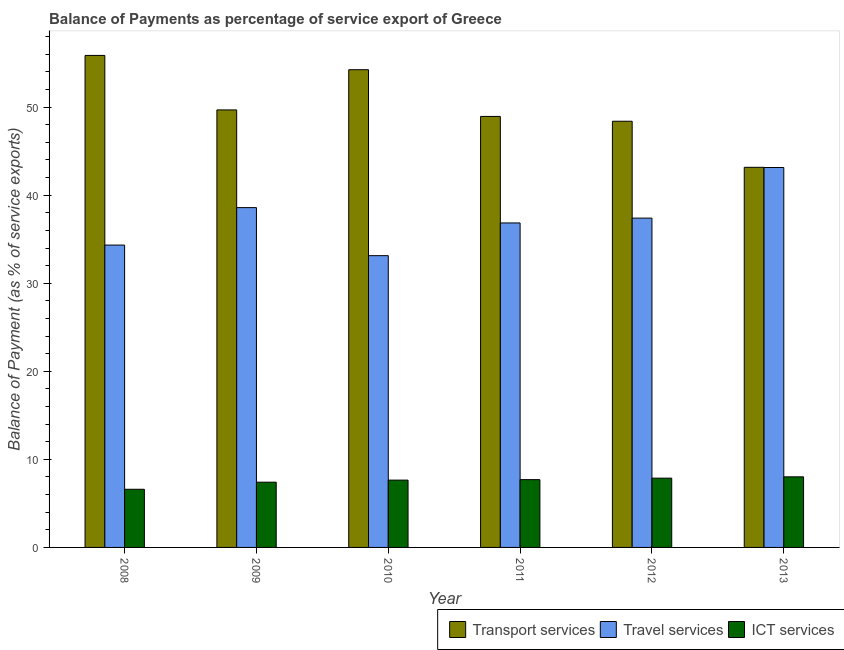Are the number of bars on each tick of the X-axis equal?
Give a very brief answer. Yes. How many bars are there on the 5th tick from the left?
Offer a terse response. 3. How many bars are there on the 6th tick from the right?
Keep it short and to the point. 3. What is the label of the 3rd group of bars from the left?
Give a very brief answer. 2010. What is the balance of payment of ict services in 2008?
Keep it short and to the point. 6.6. Across all years, what is the maximum balance of payment of ict services?
Your answer should be very brief. 8.02. Across all years, what is the minimum balance of payment of travel services?
Provide a succinct answer. 33.13. In which year was the balance of payment of transport services maximum?
Offer a terse response. 2008. In which year was the balance of payment of transport services minimum?
Your answer should be compact. 2013. What is the total balance of payment of ict services in the graph?
Offer a terse response. 45.24. What is the difference between the balance of payment of transport services in 2008 and that in 2011?
Provide a short and direct response. 6.93. What is the difference between the balance of payment of ict services in 2010 and the balance of payment of transport services in 2008?
Give a very brief answer. 1.04. What is the average balance of payment of ict services per year?
Give a very brief answer. 7.54. In the year 2010, what is the difference between the balance of payment of transport services and balance of payment of ict services?
Your answer should be compact. 0. In how many years, is the balance of payment of transport services greater than 40 %?
Ensure brevity in your answer.  6. What is the ratio of the balance of payment of ict services in 2008 to that in 2013?
Offer a terse response. 0.82. Is the difference between the balance of payment of travel services in 2009 and 2011 greater than the difference between the balance of payment of ict services in 2009 and 2011?
Your response must be concise. No. What is the difference between the highest and the second highest balance of payment of ict services?
Provide a short and direct response. 0.15. What is the difference between the highest and the lowest balance of payment of transport services?
Give a very brief answer. 12.71. What does the 1st bar from the left in 2009 represents?
Your response must be concise. Transport services. What does the 3rd bar from the right in 2008 represents?
Offer a very short reply. Transport services. Is it the case that in every year, the sum of the balance of payment of transport services and balance of payment of travel services is greater than the balance of payment of ict services?
Keep it short and to the point. Yes. What is the difference between two consecutive major ticks on the Y-axis?
Your response must be concise. 10. Are the values on the major ticks of Y-axis written in scientific E-notation?
Your response must be concise. No. Where does the legend appear in the graph?
Ensure brevity in your answer.  Bottom right. How are the legend labels stacked?
Give a very brief answer. Horizontal. What is the title of the graph?
Your answer should be very brief. Balance of Payments as percentage of service export of Greece. Does "Secondary education" appear as one of the legend labels in the graph?
Your response must be concise. No. What is the label or title of the X-axis?
Give a very brief answer. Year. What is the label or title of the Y-axis?
Provide a short and direct response. Balance of Payment (as % of service exports). What is the Balance of Payment (as % of service exports) in Transport services in 2008?
Your response must be concise. 55.87. What is the Balance of Payment (as % of service exports) of Travel services in 2008?
Provide a succinct answer. 34.33. What is the Balance of Payment (as % of service exports) in ICT services in 2008?
Offer a terse response. 6.6. What is the Balance of Payment (as % of service exports) in Transport services in 2009?
Your response must be concise. 49.68. What is the Balance of Payment (as % of service exports) in Travel services in 2009?
Offer a terse response. 38.59. What is the Balance of Payment (as % of service exports) of ICT services in 2009?
Ensure brevity in your answer.  7.41. What is the Balance of Payment (as % of service exports) in Transport services in 2010?
Your answer should be very brief. 54.25. What is the Balance of Payment (as % of service exports) of Travel services in 2010?
Give a very brief answer. 33.13. What is the Balance of Payment (as % of service exports) of ICT services in 2010?
Keep it short and to the point. 7.64. What is the Balance of Payment (as % of service exports) of Transport services in 2011?
Make the answer very short. 48.94. What is the Balance of Payment (as % of service exports) in Travel services in 2011?
Provide a succinct answer. 36.85. What is the Balance of Payment (as % of service exports) of ICT services in 2011?
Give a very brief answer. 7.7. What is the Balance of Payment (as % of service exports) in Transport services in 2012?
Offer a very short reply. 48.39. What is the Balance of Payment (as % of service exports) of Travel services in 2012?
Offer a very short reply. 37.39. What is the Balance of Payment (as % of service exports) of ICT services in 2012?
Your response must be concise. 7.87. What is the Balance of Payment (as % of service exports) in Transport services in 2013?
Provide a succinct answer. 43.16. What is the Balance of Payment (as % of service exports) in Travel services in 2013?
Give a very brief answer. 43.14. What is the Balance of Payment (as % of service exports) of ICT services in 2013?
Keep it short and to the point. 8.02. Across all years, what is the maximum Balance of Payment (as % of service exports) in Transport services?
Your answer should be very brief. 55.87. Across all years, what is the maximum Balance of Payment (as % of service exports) of Travel services?
Your response must be concise. 43.14. Across all years, what is the maximum Balance of Payment (as % of service exports) in ICT services?
Keep it short and to the point. 8.02. Across all years, what is the minimum Balance of Payment (as % of service exports) in Transport services?
Give a very brief answer. 43.16. Across all years, what is the minimum Balance of Payment (as % of service exports) of Travel services?
Your response must be concise. 33.13. Across all years, what is the minimum Balance of Payment (as % of service exports) in ICT services?
Make the answer very short. 6.6. What is the total Balance of Payment (as % of service exports) of Transport services in the graph?
Provide a short and direct response. 300.29. What is the total Balance of Payment (as % of service exports) in Travel services in the graph?
Your answer should be very brief. 223.43. What is the total Balance of Payment (as % of service exports) of ICT services in the graph?
Your response must be concise. 45.24. What is the difference between the Balance of Payment (as % of service exports) of Transport services in 2008 and that in 2009?
Ensure brevity in your answer.  6.19. What is the difference between the Balance of Payment (as % of service exports) of Travel services in 2008 and that in 2009?
Give a very brief answer. -4.25. What is the difference between the Balance of Payment (as % of service exports) of ICT services in 2008 and that in 2009?
Your answer should be very brief. -0.8. What is the difference between the Balance of Payment (as % of service exports) in Transport services in 2008 and that in 2010?
Your answer should be compact. 1.62. What is the difference between the Balance of Payment (as % of service exports) in Travel services in 2008 and that in 2010?
Provide a short and direct response. 1.2. What is the difference between the Balance of Payment (as % of service exports) in ICT services in 2008 and that in 2010?
Provide a succinct answer. -1.04. What is the difference between the Balance of Payment (as % of service exports) of Transport services in 2008 and that in 2011?
Offer a very short reply. 6.93. What is the difference between the Balance of Payment (as % of service exports) of Travel services in 2008 and that in 2011?
Offer a very short reply. -2.51. What is the difference between the Balance of Payment (as % of service exports) of ICT services in 2008 and that in 2011?
Make the answer very short. -1.09. What is the difference between the Balance of Payment (as % of service exports) in Transport services in 2008 and that in 2012?
Offer a terse response. 7.47. What is the difference between the Balance of Payment (as % of service exports) in Travel services in 2008 and that in 2012?
Keep it short and to the point. -3.06. What is the difference between the Balance of Payment (as % of service exports) of ICT services in 2008 and that in 2012?
Your answer should be very brief. -1.26. What is the difference between the Balance of Payment (as % of service exports) in Transport services in 2008 and that in 2013?
Your response must be concise. 12.71. What is the difference between the Balance of Payment (as % of service exports) of Travel services in 2008 and that in 2013?
Your response must be concise. -8.81. What is the difference between the Balance of Payment (as % of service exports) of ICT services in 2008 and that in 2013?
Give a very brief answer. -1.41. What is the difference between the Balance of Payment (as % of service exports) in Transport services in 2009 and that in 2010?
Make the answer very short. -4.57. What is the difference between the Balance of Payment (as % of service exports) of Travel services in 2009 and that in 2010?
Provide a short and direct response. 5.46. What is the difference between the Balance of Payment (as % of service exports) in ICT services in 2009 and that in 2010?
Make the answer very short. -0.24. What is the difference between the Balance of Payment (as % of service exports) in Transport services in 2009 and that in 2011?
Keep it short and to the point. 0.74. What is the difference between the Balance of Payment (as % of service exports) in Travel services in 2009 and that in 2011?
Ensure brevity in your answer.  1.74. What is the difference between the Balance of Payment (as % of service exports) of ICT services in 2009 and that in 2011?
Provide a short and direct response. -0.29. What is the difference between the Balance of Payment (as % of service exports) in Transport services in 2009 and that in 2012?
Ensure brevity in your answer.  1.29. What is the difference between the Balance of Payment (as % of service exports) in Travel services in 2009 and that in 2012?
Ensure brevity in your answer.  1.19. What is the difference between the Balance of Payment (as % of service exports) in ICT services in 2009 and that in 2012?
Keep it short and to the point. -0.46. What is the difference between the Balance of Payment (as % of service exports) in Transport services in 2009 and that in 2013?
Your answer should be compact. 6.52. What is the difference between the Balance of Payment (as % of service exports) in Travel services in 2009 and that in 2013?
Ensure brevity in your answer.  -4.55. What is the difference between the Balance of Payment (as % of service exports) of ICT services in 2009 and that in 2013?
Your response must be concise. -0.61. What is the difference between the Balance of Payment (as % of service exports) of Transport services in 2010 and that in 2011?
Your answer should be very brief. 5.31. What is the difference between the Balance of Payment (as % of service exports) of Travel services in 2010 and that in 2011?
Your response must be concise. -3.72. What is the difference between the Balance of Payment (as % of service exports) of ICT services in 2010 and that in 2011?
Give a very brief answer. -0.05. What is the difference between the Balance of Payment (as % of service exports) in Transport services in 2010 and that in 2012?
Your answer should be compact. 5.85. What is the difference between the Balance of Payment (as % of service exports) of Travel services in 2010 and that in 2012?
Offer a very short reply. -4.26. What is the difference between the Balance of Payment (as % of service exports) in ICT services in 2010 and that in 2012?
Ensure brevity in your answer.  -0.22. What is the difference between the Balance of Payment (as % of service exports) in Transport services in 2010 and that in 2013?
Your answer should be very brief. 11.08. What is the difference between the Balance of Payment (as % of service exports) in Travel services in 2010 and that in 2013?
Offer a terse response. -10.01. What is the difference between the Balance of Payment (as % of service exports) of ICT services in 2010 and that in 2013?
Your response must be concise. -0.37. What is the difference between the Balance of Payment (as % of service exports) in Transport services in 2011 and that in 2012?
Provide a succinct answer. 0.55. What is the difference between the Balance of Payment (as % of service exports) in Travel services in 2011 and that in 2012?
Your answer should be compact. -0.55. What is the difference between the Balance of Payment (as % of service exports) of ICT services in 2011 and that in 2012?
Your answer should be very brief. -0.17. What is the difference between the Balance of Payment (as % of service exports) of Transport services in 2011 and that in 2013?
Keep it short and to the point. 5.78. What is the difference between the Balance of Payment (as % of service exports) of Travel services in 2011 and that in 2013?
Offer a very short reply. -6.3. What is the difference between the Balance of Payment (as % of service exports) in ICT services in 2011 and that in 2013?
Ensure brevity in your answer.  -0.32. What is the difference between the Balance of Payment (as % of service exports) in Transport services in 2012 and that in 2013?
Your answer should be very brief. 5.23. What is the difference between the Balance of Payment (as % of service exports) in Travel services in 2012 and that in 2013?
Keep it short and to the point. -5.75. What is the difference between the Balance of Payment (as % of service exports) in ICT services in 2012 and that in 2013?
Your answer should be very brief. -0.15. What is the difference between the Balance of Payment (as % of service exports) of Transport services in 2008 and the Balance of Payment (as % of service exports) of Travel services in 2009?
Provide a succinct answer. 17.28. What is the difference between the Balance of Payment (as % of service exports) in Transport services in 2008 and the Balance of Payment (as % of service exports) in ICT services in 2009?
Offer a terse response. 48.46. What is the difference between the Balance of Payment (as % of service exports) of Travel services in 2008 and the Balance of Payment (as % of service exports) of ICT services in 2009?
Your answer should be very brief. 26.93. What is the difference between the Balance of Payment (as % of service exports) of Transport services in 2008 and the Balance of Payment (as % of service exports) of Travel services in 2010?
Make the answer very short. 22.74. What is the difference between the Balance of Payment (as % of service exports) of Transport services in 2008 and the Balance of Payment (as % of service exports) of ICT services in 2010?
Ensure brevity in your answer.  48.22. What is the difference between the Balance of Payment (as % of service exports) in Travel services in 2008 and the Balance of Payment (as % of service exports) in ICT services in 2010?
Give a very brief answer. 26.69. What is the difference between the Balance of Payment (as % of service exports) of Transport services in 2008 and the Balance of Payment (as % of service exports) of Travel services in 2011?
Offer a very short reply. 19.02. What is the difference between the Balance of Payment (as % of service exports) of Transport services in 2008 and the Balance of Payment (as % of service exports) of ICT services in 2011?
Keep it short and to the point. 48.17. What is the difference between the Balance of Payment (as % of service exports) of Travel services in 2008 and the Balance of Payment (as % of service exports) of ICT services in 2011?
Give a very brief answer. 26.64. What is the difference between the Balance of Payment (as % of service exports) in Transport services in 2008 and the Balance of Payment (as % of service exports) in Travel services in 2012?
Ensure brevity in your answer.  18.47. What is the difference between the Balance of Payment (as % of service exports) of Transport services in 2008 and the Balance of Payment (as % of service exports) of ICT services in 2012?
Offer a very short reply. 48. What is the difference between the Balance of Payment (as % of service exports) in Travel services in 2008 and the Balance of Payment (as % of service exports) in ICT services in 2012?
Keep it short and to the point. 26.47. What is the difference between the Balance of Payment (as % of service exports) of Transport services in 2008 and the Balance of Payment (as % of service exports) of Travel services in 2013?
Keep it short and to the point. 12.73. What is the difference between the Balance of Payment (as % of service exports) in Transport services in 2008 and the Balance of Payment (as % of service exports) in ICT services in 2013?
Your answer should be very brief. 47.85. What is the difference between the Balance of Payment (as % of service exports) in Travel services in 2008 and the Balance of Payment (as % of service exports) in ICT services in 2013?
Keep it short and to the point. 26.32. What is the difference between the Balance of Payment (as % of service exports) of Transport services in 2009 and the Balance of Payment (as % of service exports) of Travel services in 2010?
Your response must be concise. 16.55. What is the difference between the Balance of Payment (as % of service exports) of Transport services in 2009 and the Balance of Payment (as % of service exports) of ICT services in 2010?
Keep it short and to the point. 42.04. What is the difference between the Balance of Payment (as % of service exports) of Travel services in 2009 and the Balance of Payment (as % of service exports) of ICT services in 2010?
Provide a succinct answer. 30.94. What is the difference between the Balance of Payment (as % of service exports) of Transport services in 2009 and the Balance of Payment (as % of service exports) of Travel services in 2011?
Give a very brief answer. 12.83. What is the difference between the Balance of Payment (as % of service exports) in Transport services in 2009 and the Balance of Payment (as % of service exports) in ICT services in 2011?
Offer a terse response. 41.98. What is the difference between the Balance of Payment (as % of service exports) in Travel services in 2009 and the Balance of Payment (as % of service exports) in ICT services in 2011?
Provide a short and direct response. 30.89. What is the difference between the Balance of Payment (as % of service exports) of Transport services in 2009 and the Balance of Payment (as % of service exports) of Travel services in 2012?
Your answer should be compact. 12.29. What is the difference between the Balance of Payment (as % of service exports) of Transport services in 2009 and the Balance of Payment (as % of service exports) of ICT services in 2012?
Provide a short and direct response. 41.81. What is the difference between the Balance of Payment (as % of service exports) of Travel services in 2009 and the Balance of Payment (as % of service exports) of ICT services in 2012?
Keep it short and to the point. 30.72. What is the difference between the Balance of Payment (as % of service exports) of Transport services in 2009 and the Balance of Payment (as % of service exports) of Travel services in 2013?
Provide a short and direct response. 6.54. What is the difference between the Balance of Payment (as % of service exports) in Transport services in 2009 and the Balance of Payment (as % of service exports) in ICT services in 2013?
Your answer should be compact. 41.66. What is the difference between the Balance of Payment (as % of service exports) in Travel services in 2009 and the Balance of Payment (as % of service exports) in ICT services in 2013?
Provide a succinct answer. 30.57. What is the difference between the Balance of Payment (as % of service exports) of Transport services in 2010 and the Balance of Payment (as % of service exports) of Travel services in 2011?
Provide a short and direct response. 17.4. What is the difference between the Balance of Payment (as % of service exports) in Transport services in 2010 and the Balance of Payment (as % of service exports) in ICT services in 2011?
Give a very brief answer. 46.55. What is the difference between the Balance of Payment (as % of service exports) of Travel services in 2010 and the Balance of Payment (as % of service exports) of ICT services in 2011?
Your answer should be compact. 25.43. What is the difference between the Balance of Payment (as % of service exports) of Transport services in 2010 and the Balance of Payment (as % of service exports) of Travel services in 2012?
Provide a succinct answer. 16.85. What is the difference between the Balance of Payment (as % of service exports) in Transport services in 2010 and the Balance of Payment (as % of service exports) in ICT services in 2012?
Provide a succinct answer. 46.38. What is the difference between the Balance of Payment (as % of service exports) in Travel services in 2010 and the Balance of Payment (as % of service exports) in ICT services in 2012?
Give a very brief answer. 25.26. What is the difference between the Balance of Payment (as % of service exports) of Transport services in 2010 and the Balance of Payment (as % of service exports) of Travel services in 2013?
Your answer should be very brief. 11.1. What is the difference between the Balance of Payment (as % of service exports) in Transport services in 2010 and the Balance of Payment (as % of service exports) in ICT services in 2013?
Your response must be concise. 46.23. What is the difference between the Balance of Payment (as % of service exports) in Travel services in 2010 and the Balance of Payment (as % of service exports) in ICT services in 2013?
Offer a very short reply. 25.11. What is the difference between the Balance of Payment (as % of service exports) of Transport services in 2011 and the Balance of Payment (as % of service exports) of Travel services in 2012?
Make the answer very short. 11.55. What is the difference between the Balance of Payment (as % of service exports) of Transport services in 2011 and the Balance of Payment (as % of service exports) of ICT services in 2012?
Your answer should be compact. 41.07. What is the difference between the Balance of Payment (as % of service exports) in Travel services in 2011 and the Balance of Payment (as % of service exports) in ICT services in 2012?
Give a very brief answer. 28.98. What is the difference between the Balance of Payment (as % of service exports) in Transport services in 2011 and the Balance of Payment (as % of service exports) in Travel services in 2013?
Offer a very short reply. 5.8. What is the difference between the Balance of Payment (as % of service exports) in Transport services in 2011 and the Balance of Payment (as % of service exports) in ICT services in 2013?
Your response must be concise. 40.92. What is the difference between the Balance of Payment (as % of service exports) of Travel services in 2011 and the Balance of Payment (as % of service exports) of ICT services in 2013?
Your answer should be very brief. 28.83. What is the difference between the Balance of Payment (as % of service exports) in Transport services in 2012 and the Balance of Payment (as % of service exports) in Travel services in 2013?
Ensure brevity in your answer.  5.25. What is the difference between the Balance of Payment (as % of service exports) of Transport services in 2012 and the Balance of Payment (as % of service exports) of ICT services in 2013?
Ensure brevity in your answer.  40.38. What is the difference between the Balance of Payment (as % of service exports) of Travel services in 2012 and the Balance of Payment (as % of service exports) of ICT services in 2013?
Your answer should be compact. 29.38. What is the average Balance of Payment (as % of service exports) in Transport services per year?
Give a very brief answer. 50.05. What is the average Balance of Payment (as % of service exports) in Travel services per year?
Offer a terse response. 37.24. What is the average Balance of Payment (as % of service exports) in ICT services per year?
Provide a succinct answer. 7.54. In the year 2008, what is the difference between the Balance of Payment (as % of service exports) in Transport services and Balance of Payment (as % of service exports) in Travel services?
Provide a succinct answer. 21.53. In the year 2008, what is the difference between the Balance of Payment (as % of service exports) in Transport services and Balance of Payment (as % of service exports) in ICT services?
Offer a terse response. 49.26. In the year 2008, what is the difference between the Balance of Payment (as % of service exports) of Travel services and Balance of Payment (as % of service exports) of ICT services?
Make the answer very short. 27.73. In the year 2009, what is the difference between the Balance of Payment (as % of service exports) of Transport services and Balance of Payment (as % of service exports) of Travel services?
Your response must be concise. 11.09. In the year 2009, what is the difference between the Balance of Payment (as % of service exports) of Transport services and Balance of Payment (as % of service exports) of ICT services?
Give a very brief answer. 42.27. In the year 2009, what is the difference between the Balance of Payment (as % of service exports) in Travel services and Balance of Payment (as % of service exports) in ICT services?
Your answer should be compact. 31.18. In the year 2010, what is the difference between the Balance of Payment (as % of service exports) in Transport services and Balance of Payment (as % of service exports) in Travel services?
Your answer should be compact. 21.12. In the year 2010, what is the difference between the Balance of Payment (as % of service exports) of Transport services and Balance of Payment (as % of service exports) of ICT services?
Provide a succinct answer. 46.6. In the year 2010, what is the difference between the Balance of Payment (as % of service exports) of Travel services and Balance of Payment (as % of service exports) of ICT services?
Your answer should be very brief. 25.49. In the year 2011, what is the difference between the Balance of Payment (as % of service exports) of Transport services and Balance of Payment (as % of service exports) of Travel services?
Offer a terse response. 12.09. In the year 2011, what is the difference between the Balance of Payment (as % of service exports) of Transport services and Balance of Payment (as % of service exports) of ICT services?
Make the answer very short. 41.24. In the year 2011, what is the difference between the Balance of Payment (as % of service exports) of Travel services and Balance of Payment (as % of service exports) of ICT services?
Keep it short and to the point. 29.15. In the year 2012, what is the difference between the Balance of Payment (as % of service exports) in Transport services and Balance of Payment (as % of service exports) in Travel services?
Ensure brevity in your answer.  11. In the year 2012, what is the difference between the Balance of Payment (as % of service exports) in Transport services and Balance of Payment (as % of service exports) in ICT services?
Provide a short and direct response. 40.53. In the year 2012, what is the difference between the Balance of Payment (as % of service exports) of Travel services and Balance of Payment (as % of service exports) of ICT services?
Your answer should be compact. 29.53. In the year 2013, what is the difference between the Balance of Payment (as % of service exports) in Transport services and Balance of Payment (as % of service exports) in Travel services?
Give a very brief answer. 0.02. In the year 2013, what is the difference between the Balance of Payment (as % of service exports) of Transport services and Balance of Payment (as % of service exports) of ICT services?
Provide a short and direct response. 35.15. In the year 2013, what is the difference between the Balance of Payment (as % of service exports) of Travel services and Balance of Payment (as % of service exports) of ICT services?
Your answer should be very brief. 35.13. What is the ratio of the Balance of Payment (as % of service exports) in Transport services in 2008 to that in 2009?
Keep it short and to the point. 1.12. What is the ratio of the Balance of Payment (as % of service exports) in Travel services in 2008 to that in 2009?
Offer a very short reply. 0.89. What is the ratio of the Balance of Payment (as % of service exports) of ICT services in 2008 to that in 2009?
Provide a succinct answer. 0.89. What is the ratio of the Balance of Payment (as % of service exports) in Transport services in 2008 to that in 2010?
Your answer should be very brief. 1.03. What is the ratio of the Balance of Payment (as % of service exports) of Travel services in 2008 to that in 2010?
Provide a succinct answer. 1.04. What is the ratio of the Balance of Payment (as % of service exports) in ICT services in 2008 to that in 2010?
Provide a succinct answer. 0.86. What is the ratio of the Balance of Payment (as % of service exports) of Transport services in 2008 to that in 2011?
Make the answer very short. 1.14. What is the ratio of the Balance of Payment (as % of service exports) of Travel services in 2008 to that in 2011?
Your answer should be compact. 0.93. What is the ratio of the Balance of Payment (as % of service exports) of ICT services in 2008 to that in 2011?
Your answer should be compact. 0.86. What is the ratio of the Balance of Payment (as % of service exports) of Transport services in 2008 to that in 2012?
Your answer should be very brief. 1.15. What is the ratio of the Balance of Payment (as % of service exports) of Travel services in 2008 to that in 2012?
Provide a short and direct response. 0.92. What is the ratio of the Balance of Payment (as % of service exports) of ICT services in 2008 to that in 2012?
Give a very brief answer. 0.84. What is the ratio of the Balance of Payment (as % of service exports) in Transport services in 2008 to that in 2013?
Provide a succinct answer. 1.29. What is the ratio of the Balance of Payment (as % of service exports) of Travel services in 2008 to that in 2013?
Your answer should be very brief. 0.8. What is the ratio of the Balance of Payment (as % of service exports) in ICT services in 2008 to that in 2013?
Offer a terse response. 0.82. What is the ratio of the Balance of Payment (as % of service exports) of Transport services in 2009 to that in 2010?
Offer a very short reply. 0.92. What is the ratio of the Balance of Payment (as % of service exports) in Travel services in 2009 to that in 2010?
Offer a very short reply. 1.16. What is the ratio of the Balance of Payment (as % of service exports) in ICT services in 2009 to that in 2010?
Your answer should be compact. 0.97. What is the ratio of the Balance of Payment (as % of service exports) of Transport services in 2009 to that in 2011?
Offer a very short reply. 1.02. What is the ratio of the Balance of Payment (as % of service exports) in Travel services in 2009 to that in 2011?
Offer a very short reply. 1.05. What is the ratio of the Balance of Payment (as % of service exports) in ICT services in 2009 to that in 2011?
Make the answer very short. 0.96. What is the ratio of the Balance of Payment (as % of service exports) in Transport services in 2009 to that in 2012?
Your response must be concise. 1.03. What is the ratio of the Balance of Payment (as % of service exports) in Travel services in 2009 to that in 2012?
Ensure brevity in your answer.  1.03. What is the ratio of the Balance of Payment (as % of service exports) in ICT services in 2009 to that in 2012?
Your answer should be compact. 0.94. What is the ratio of the Balance of Payment (as % of service exports) of Transport services in 2009 to that in 2013?
Your answer should be very brief. 1.15. What is the ratio of the Balance of Payment (as % of service exports) of Travel services in 2009 to that in 2013?
Offer a terse response. 0.89. What is the ratio of the Balance of Payment (as % of service exports) of ICT services in 2009 to that in 2013?
Provide a succinct answer. 0.92. What is the ratio of the Balance of Payment (as % of service exports) of Transport services in 2010 to that in 2011?
Ensure brevity in your answer.  1.11. What is the ratio of the Balance of Payment (as % of service exports) in Travel services in 2010 to that in 2011?
Provide a succinct answer. 0.9. What is the ratio of the Balance of Payment (as % of service exports) in ICT services in 2010 to that in 2011?
Your answer should be very brief. 0.99. What is the ratio of the Balance of Payment (as % of service exports) in Transport services in 2010 to that in 2012?
Provide a succinct answer. 1.12. What is the ratio of the Balance of Payment (as % of service exports) of Travel services in 2010 to that in 2012?
Give a very brief answer. 0.89. What is the ratio of the Balance of Payment (as % of service exports) in ICT services in 2010 to that in 2012?
Give a very brief answer. 0.97. What is the ratio of the Balance of Payment (as % of service exports) in Transport services in 2010 to that in 2013?
Give a very brief answer. 1.26. What is the ratio of the Balance of Payment (as % of service exports) in Travel services in 2010 to that in 2013?
Your response must be concise. 0.77. What is the ratio of the Balance of Payment (as % of service exports) in ICT services in 2010 to that in 2013?
Keep it short and to the point. 0.95. What is the ratio of the Balance of Payment (as % of service exports) in Transport services in 2011 to that in 2012?
Give a very brief answer. 1.01. What is the ratio of the Balance of Payment (as % of service exports) in Travel services in 2011 to that in 2012?
Keep it short and to the point. 0.99. What is the ratio of the Balance of Payment (as % of service exports) of ICT services in 2011 to that in 2012?
Offer a very short reply. 0.98. What is the ratio of the Balance of Payment (as % of service exports) in Transport services in 2011 to that in 2013?
Keep it short and to the point. 1.13. What is the ratio of the Balance of Payment (as % of service exports) of Travel services in 2011 to that in 2013?
Keep it short and to the point. 0.85. What is the ratio of the Balance of Payment (as % of service exports) in ICT services in 2011 to that in 2013?
Make the answer very short. 0.96. What is the ratio of the Balance of Payment (as % of service exports) in Transport services in 2012 to that in 2013?
Make the answer very short. 1.12. What is the ratio of the Balance of Payment (as % of service exports) of Travel services in 2012 to that in 2013?
Make the answer very short. 0.87. What is the ratio of the Balance of Payment (as % of service exports) of ICT services in 2012 to that in 2013?
Your answer should be very brief. 0.98. What is the difference between the highest and the second highest Balance of Payment (as % of service exports) of Transport services?
Offer a very short reply. 1.62. What is the difference between the highest and the second highest Balance of Payment (as % of service exports) in Travel services?
Offer a very short reply. 4.55. What is the difference between the highest and the second highest Balance of Payment (as % of service exports) in ICT services?
Make the answer very short. 0.15. What is the difference between the highest and the lowest Balance of Payment (as % of service exports) of Transport services?
Offer a terse response. 12.71. What is the difference between the highest and the lowest Balance of Payment (as % of service exports) of Travel services?
Ensure brevity in your answer.  10.01. What is the difference between the highest and the lowest Balance of Payment (as % of service exports) in ICT services?
Your answer should be very brief. 1.41. 